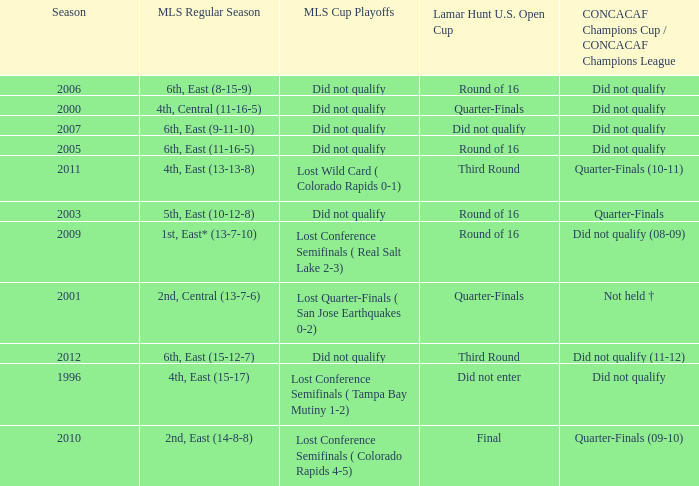How many mls cup playoffs where there for the mls regular season is 1st, east* (13-7-10)? 1.0. 